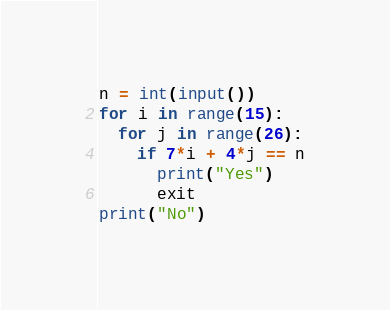Convert code to text. <code><loc_0><loc_0><loc_500><loc_500><_Python_>n = int(input())
for i in range(15):
  for j in range(26):
    if 7*i + 4*j == n
      print("Yes")
      exit 
print("No")</code> 